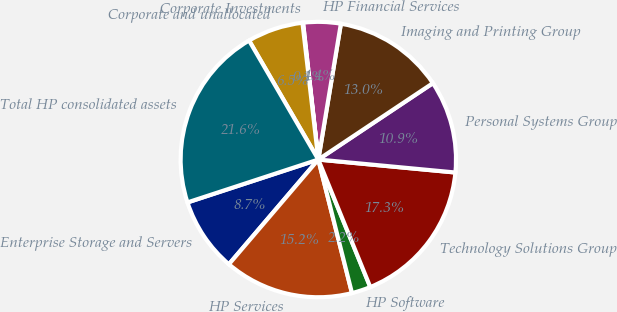Convert chart to OTSL. <chart><loc_0><loc_0><loc_500><loc_500><pie_chart><fcel>Enterprise Storage and Servers<fcel>HP Services<fcel>HP Software<fcel>Technology Solutions Group<fcel>Personal Systems Group<fcel>Imaging and Printing Group<fcel>HP Financial Services<fcel>Corporate Investments<fcel>Corporate and unallocated<fcel>Total HP consolidated assets<nl><fcel>8.71%<fcel>15.18%<fcel>2.23%<fcel>17.34%<fcel>10.86%<fcel>13.02%<fcel>4.39%<fcel>0.07%<fcel>6.55%<fcel>21.65%<nl></chart> 